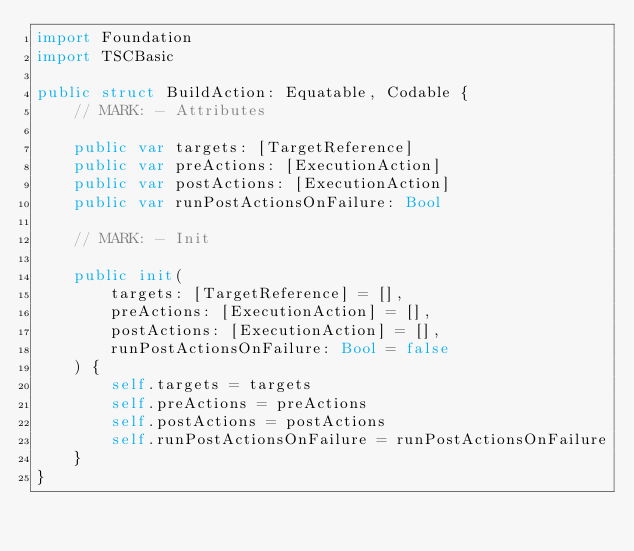<code> <loc_0><loc_0><loc_500><loc_500><_Swift_>import Foundation
import TSCBasic

public struct BuildAction: Equatable, Codable {
    // MARK: - Attributes

    public var targets: [TargetReference]
    public var preActions: [ExecutionAction]
    public var postActions: [ExecutionAction]
    public var runPostActionsOnFailure: Bool

    // MARK: - Init

    public init(
        targets: [TargetReference] = [],
        preActions: [ExecutionAction] = [],
        postActions: [ExecutionAction] = [],
        runPostActionsOnFailure: Bool = false
    ) {
        self.targets = targets
        self.preActions = preActions
        self.postActions = postActions
        self.runPostActionsOnFailure = runPostActionsOnFailure
    }
}
</code> 